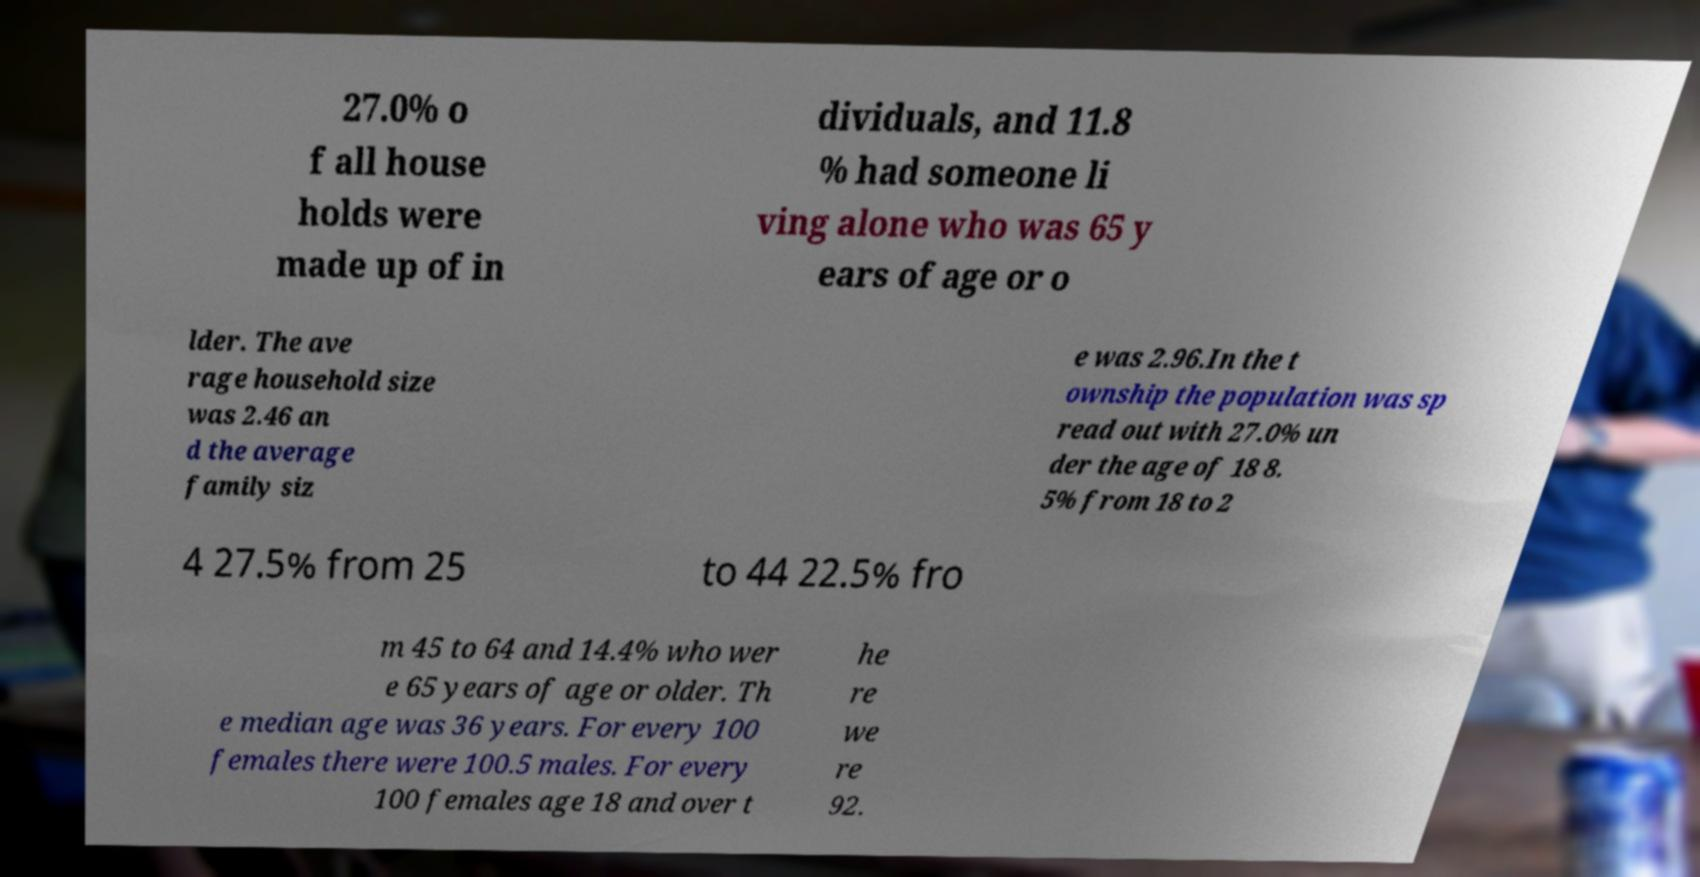Could you extract and type out the text from this image? 27.0% o f all house holds were made up of in dividuals, and 11.8 % had someone li ving alone who was 65 y ears of age or o lder. The ave rage household size was 2.46 an d the average family siz e was 2.96.In the t ownship the population was sp read out with 27.0% un der the age of 18 8. 5% from 18 to 2 4 27.5% from 25 to 44 22.5% fro m 45 to 64 and 14.4% who wer e 65 years of age or older. Th e median age was 36 years. For every 100 females there were 100.5 males. For every 100 females age 18 and over t he re we re 92. 